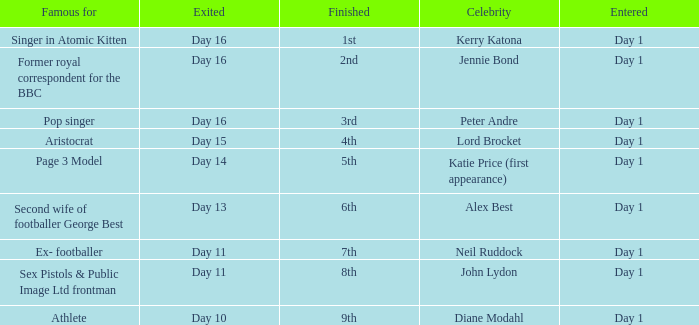Name the entered for famous for page 3 model Day 1. I'm looking to parse the entire table for insights. Could you assist me with that? {'header': ['Famous for', 'Exited', 'Finished', 'Celebrity', 'Entered'], 'rows': [['Singer in Atomic Kitten', 'Day 16', '1st', 'Kerry Katona', 'Day 1'], ['Former royal correspondent for the BBC', 'Day 16', '2nd', 'Jennie Bond', 'Day 1'], ['Pop singer', 'Day 16', '3rd', 'Peter Andre', 'Day 1'], ['Aristocrat', 'Day 15', '4th', 'Lord Brocket', 'Day 1'], ['Page 3 Model', 'Day 14', '5th', 'Katie Price (first appearance)', 'Day 1'], ['Second wife of footballer George Best', 'Day 13', '6th', 'Alex Best', 'Day 1'], ['Ex- footballer', 'Day 11', '7th', 'Neil Ruddock', 'Day 1'], ['Sex Pistols & Public Image Ltd frontman', 'Day 11', '8th', 'John Lydon', 'Day 1'], ['Athlete', 'Day 10', '9th', 'Diane Modahl', 'Day 1']]} 